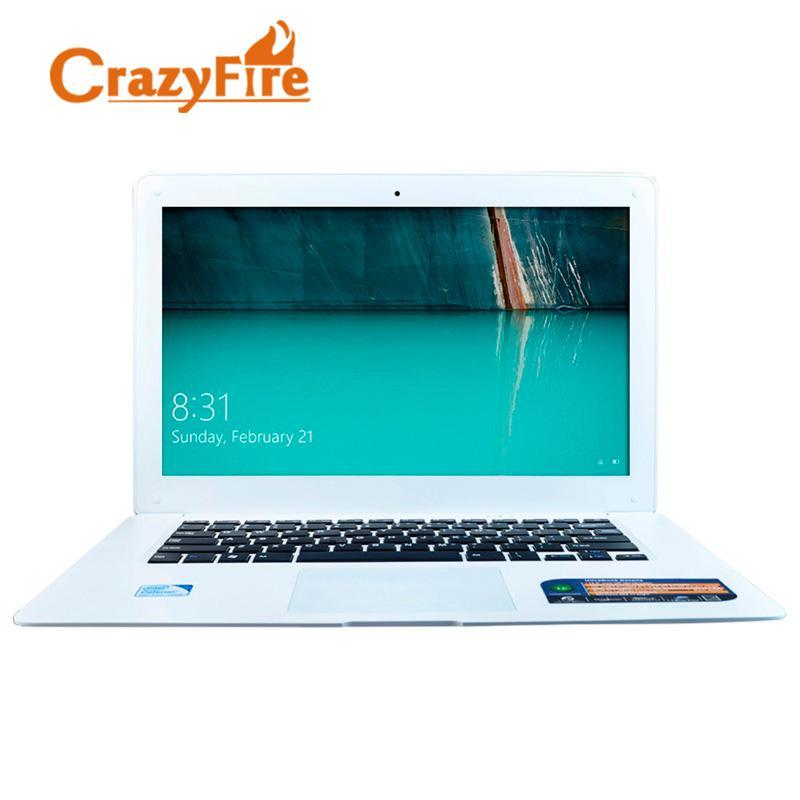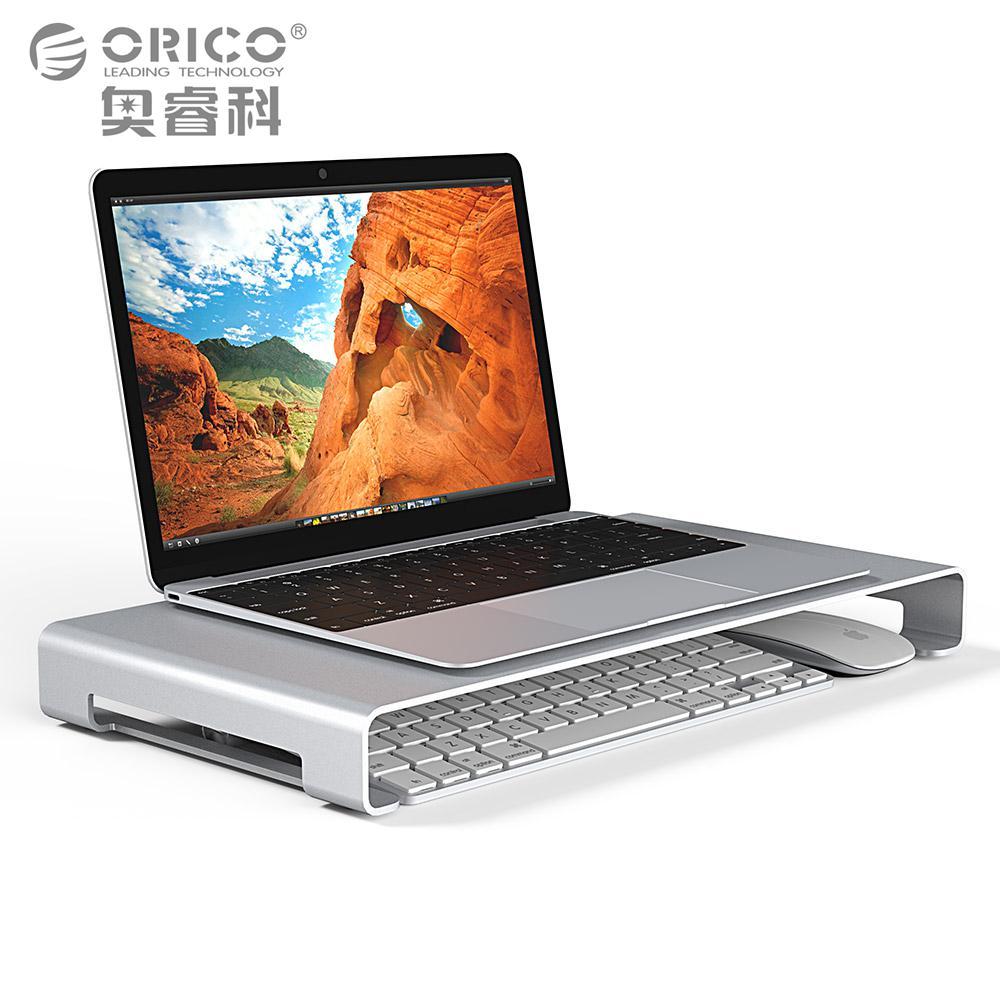The first image is the image on the left, the second image is the image on the right. Analyze the images presented: Is the assertion "There is a black laptop to the left of a lighter colored laptop" valid? Answer yes or no. No. The first image is the image on the left, the second image is the image on the right. Given the left and right images, does the statement "One fully open laptop computer is black, and a second laptop is a different color." hold true? Answer yes or no. No. 